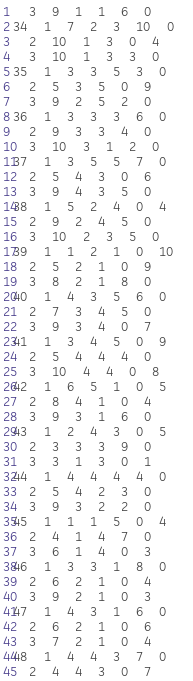Convert code to text. <code><loc_0><loc_0><loc_500><loc_500><_ObjectiveC_>	3	9	1	1	6	0	
34	1	7	2	3	10	0	
	2	10	1	3	0	4	
	3	10	1	3	3	0	
35	1	3	3	5	3	0	
	2	5	3	5	0	9	
	3	9	2	5	2	0	
36	1	3	3	3	6	0	
	2	9	3	3	4	0	
	3	10	3	1	2	0	
37	1	3	5	5	7	0	
	2	5	4	3	0	6	
	3	9	4	3	5	0	
38	1	5	2	4	0	4	
	2	9	2	4	5	0	
	3	10	2	3	5	0	
39	1	1	2	1	0	10	
	2	5	2	1	0	9	
	3	8	2	1	8	0	
40	1	4	3	5	6	0	
	2	7	3	4	5	0	
	3	9	3	4	0	7	
41	1	3	4	5	0	9	
	2	5	4	4	4	0	
	3	10	4	4	0	8	
42	1	6	5	1	0	5	
	2	8	4	1	0	4	
	3	9	3	1	6	0	
43	1	2	4	3	0	5	
	2	3	3	3	9	0	
	3	3	1	3	0	1	
44	1	4	4	4	4	0	
	2	5	4	2	3	0	
	3	9	3	2	2	0	
45	1	1	1	5	0	4	
	2	4	1	4	7	0	
	3	6	1	4	0	3	
46	1	3	3	1	8	0	
	2	6	2	1	0	4	
	3	9	2	1	0	3	
47	1	4	3	1	6	0	
	2	6	2	1	0	6	
	3	7	2	1	0	4	
48	1	4	4	3	7	0	
	2	4	4	3	0	7	</code> 